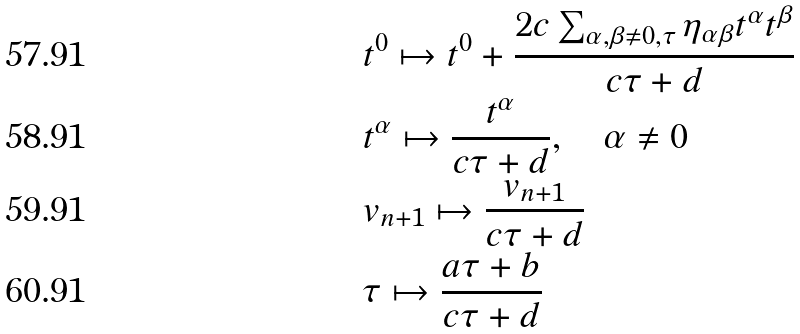<formula> <loc_0><loc_0><loc_500><loc_500>& t ^ { 0 } \mapsto t ^ { 0 } + \frac { 2 c \sum _ { \alpha , \beta \neq 0 , \tau } \eta _ { \alpha \beta } t ^ { \alpha } t ^ { \beta } } { c \tau + d } \\ & t ^ { \alpha } \mapsto \frac { t ^ { \alpha } } { c \tau + d } , \quad \alpha \neq 0 \\ & v _ { n + 1 } \mapsto \frac { v _ { n + 1 } } { c \tau + d } \\ & \tau \mapsto \frac { a \tau + b } { c \tau + d }</formula> 